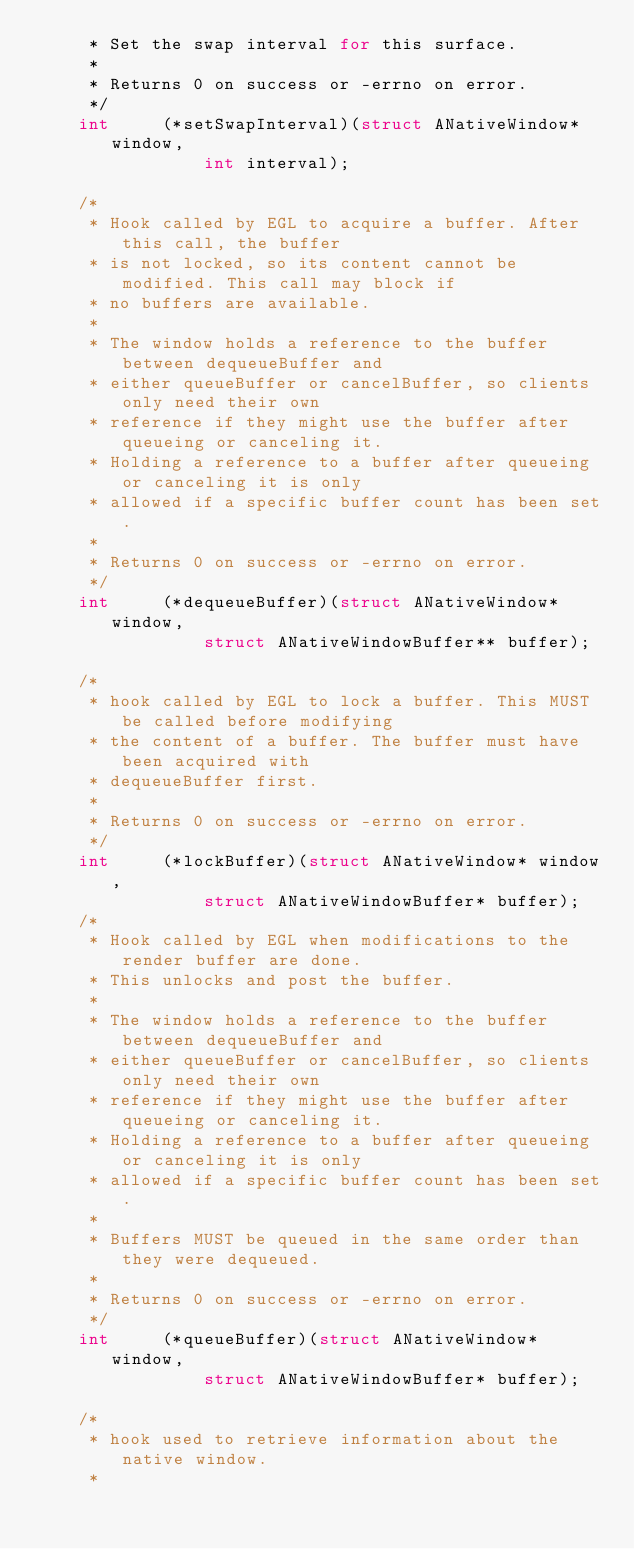<code> <loc_0><loc_0><loc_500><loc_500><_C_>     * Set the swap interval for this surface.
     *
     * Returns 0 on success or -errno on error.
     */
    int     (*setSwapInterval)(struct ANativeWindow* window,
                int interval);

    /*
     * Hook called by EGL to acquire a buffer. After this call, the buffer
     * is not locked, so its content cannot be modified. This call may block if
     * no buffers are available.
     *
     * The window holds a reference to the buffer between dequeueBuffer and
     * either queueBuffer or cancelBuffer, so clients only need their own
     * reference if they might use the buffer after queueing or canceling it.
     * Holding a reference to a buffer after queueing or canceling it is only
     * allowed if a specific buffer count has been set.
     *
     * Returns 0 on success or -errno on error.
     */
    int     (*dequeueBuffer)(struct ANativeWindow* window,
                struct ANativeWindowBuffer** buffer);

    /*
     * hook called by EGL to lock a buffer. This MUST be called before modifying
     * the content of a buffer. The buffer must have been acquired with
     * dequeueBuffer first.
     *
     * Returns 0 on success or -errno on error.
     */
    int     (*lockBuffer)(struct ANativeWindow* window,
                struct ANativeWindowBuffer* buffer);
    /*
     * Hook called by EGL when modifications to the render buffer are done.
     * This unlocks and post the buffer.
     *
     * The window holds a reference to the buffer between dequeueBuffer and
     * either queueBuffer or cancelBuffer, so clients only need their own
     * reference if they might use the buffer after queueing or canceling it.
     * Holding a reference to a buffer after queueing or canceling it is only
     * allowed if a specific buffer count has been set.
     *
     * Buffers MUST be queued in the same order than they were dequeued.
     *
     * Returns 0 on success or -errno on error.
     */
    int     (*queueBuffer)(struct ANativeWindow* window,
                struct ANativeWindowBuffer* buffer);

    /*
     * hook used to retrieve information about the native window.
     *</code> 